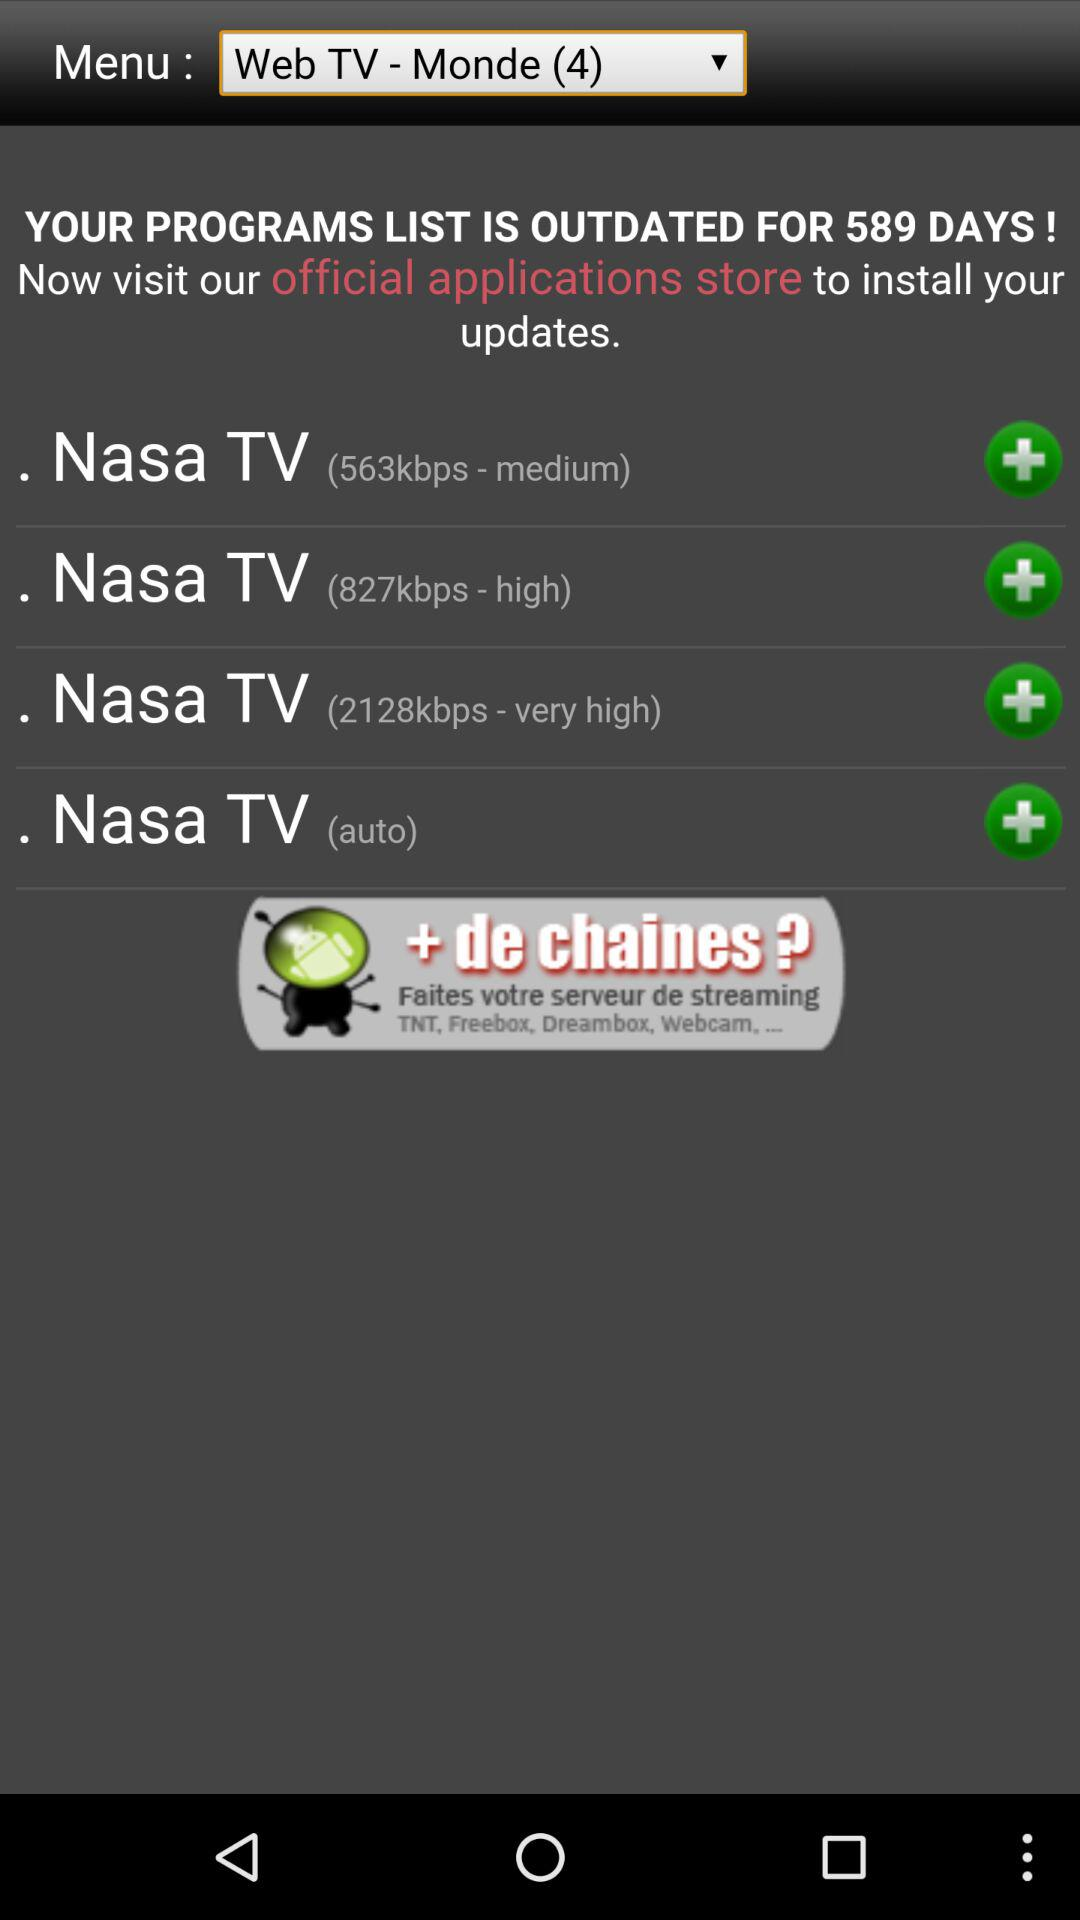In medium, how many Kbps does "Nasa TV" have? "Nasa TV" has 563 kbps. 